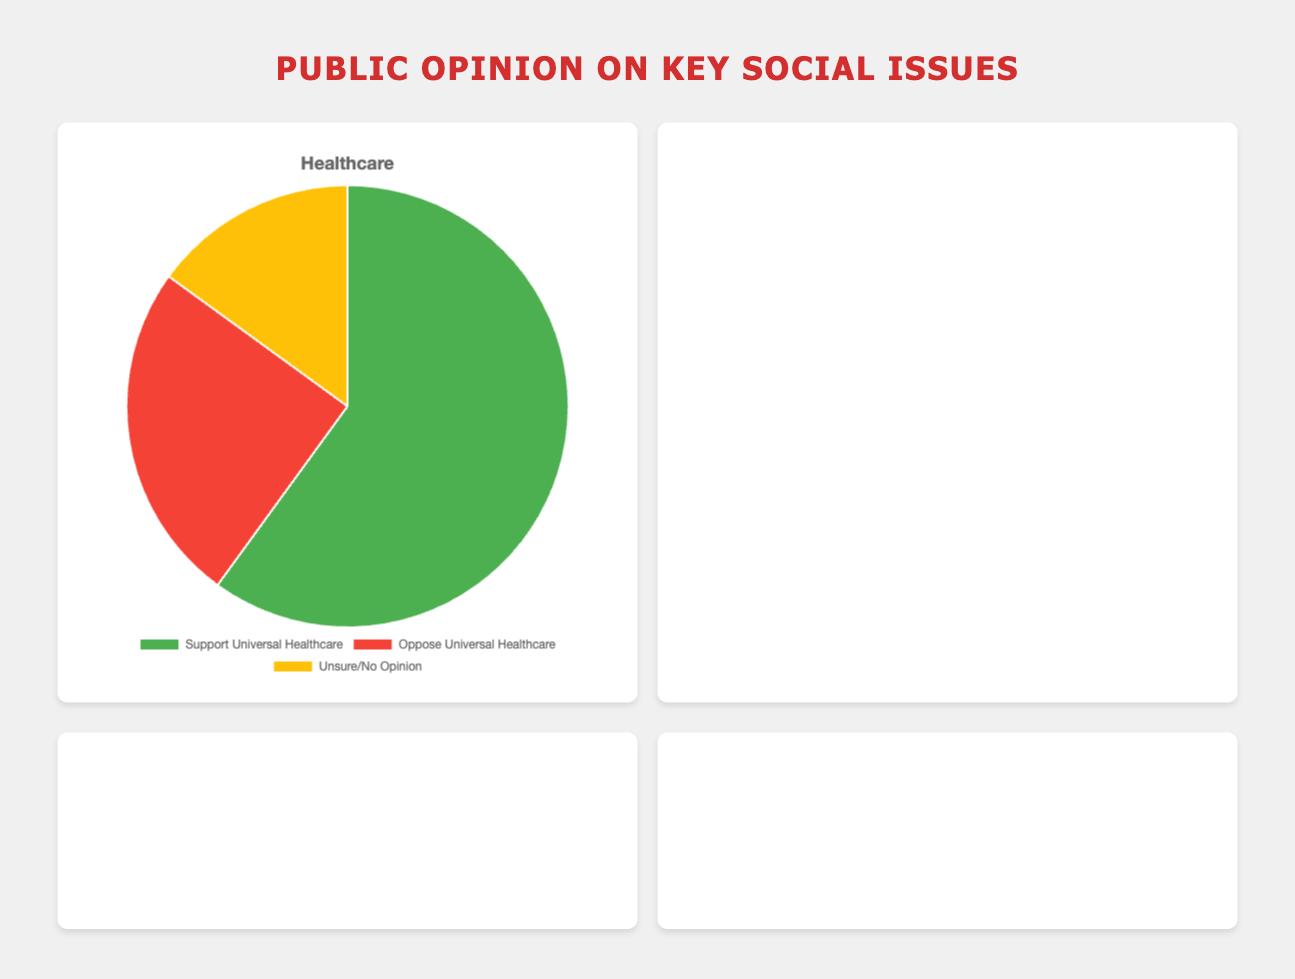What percentage of people support Universal Healthcare? The slice labeled "Support Universal Healthcare" shows 60%. So, the percentage of people supporting Universal Healthcare is 60%.
Answer: 60% Which issue has the highest percentage of people believing it is a major issue or concern? By comparing the slices of each chart, the "Believe in Human-Caused Climate Change" slice is the largest at 70%, which is higher compared to the largest slices of Healthcare (60%), Income Inequality (65%), and Racial Justice (55%).
Answer: Climate Change What is the combined percentage of people who are unsure or have no opinion across all issues? Sum the "Unsure/No Opinion" percentages from each issue: 15% (Healthcare) + 10% (Climate Change) + 15% (Income Inequality) + 15% (Racial Justice) = 55%.
Answer: 55% How much larger is the percentage of people supporting Universal Healthcare compared to those opposing it? The percentage supporting Universal Healthcare is 60%, and the percentage opposing is 25%. The difference is 60% - 25% = 35%.
Answer: 35% In which issue is the percentage of people who do not believe or oppose the issue the highest? The "Oppose Racial Justice Movements" slice is 30%, which is higher than "Oppose Universal Healthcare" at 25% and "Do Not Believe in Human-Caused Climate Change" at 20%. Compare these to determine the highest.
Answer: Racial Justice What is the average percentage of support or belief in the major issues (excluding those who are unsure or have no opinion)? The percentage of support or belief for each issue are: 60% (Healthcare), 70% (Climate Change), 65% (Income Inequality), 55% (Racial Justice). The average is calculated as (60% + 70% + 65% + 55%) / 4 = 62.5%.
Answer: 62.5% How much greater is the percentage of people who believe in Human-Caused Climate Change compared to those who are unsure or have no opinion about Climate Change? The percentage who believe is 70%, while those who are unsure or have no opinion are 10%. The difference is 70% - 10% = 60%.
Answer: 60% Which issue has the lowest percentage of people who are unsure or have no opinion? By comparing the slices for "Unsure/No Opinion", the slices for Healthcare, Income Inequality, and Racial Justice are 15%, while Climate Change is only 10%.
Answer: Climate Change 